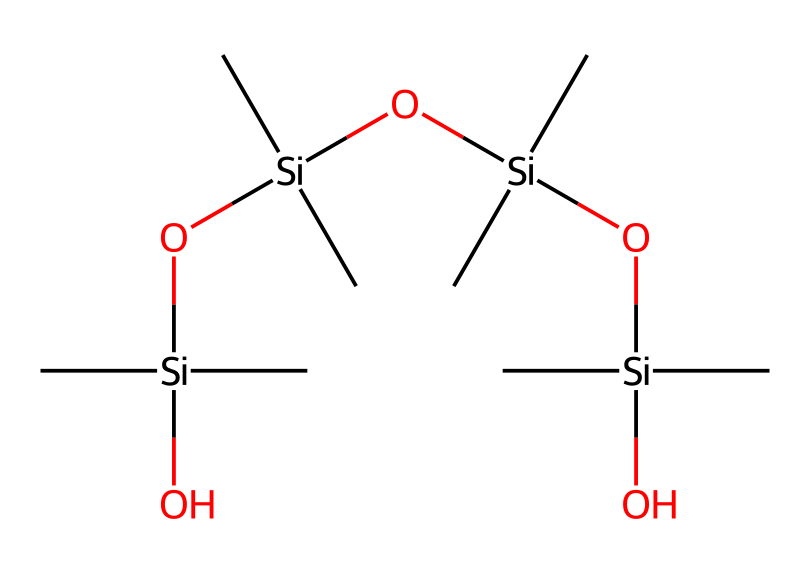How many silicon atoms are present in this chemical structure? The SMILES representation contains multiple occurrences of the silicon element represented by [Si]. Counting the instances of [Si], there are four silicon atoms present in the structure.
Answer: four What is the main functional group present in this organosilicon compound? The chemical structure prominently features hydroxyl groups (-OH) connected to silicon atoms, which is indicative of silanol functional groups. This is key in determining its adhesive properties.
Answer: silanol What type of bonding is primarily responsible for the flexibility of this silicone-based adhesive? The presence of silicon-oxygen bonds (Si-O) creates a unique polymeric chain that contributes to the flexibility of silicone adhesives, allowing them to withstand various strains without breaking.
Answer: silicon-oxygen bonds How does the arrangement of alkyl groups influence the properties of this adhesive? The alkyl groups (represented by the 'C' in the structure) provide hydrophobic characteristics, which enhance the adhesive's resistance to moisture and environmental conditions, improving overall durability.
Answer: hydrophobic characteristics What makes this compound effective as a silicone adhesive for household repairs? The combination of silanol groups (for bonding) and hydrophobic alkyl chains (for moisture resistance) results in a strong adhesive that adheres well to various surfaces while remaining flexible, making it ideal for repairs.
Answer: strong and flexible adhesive 